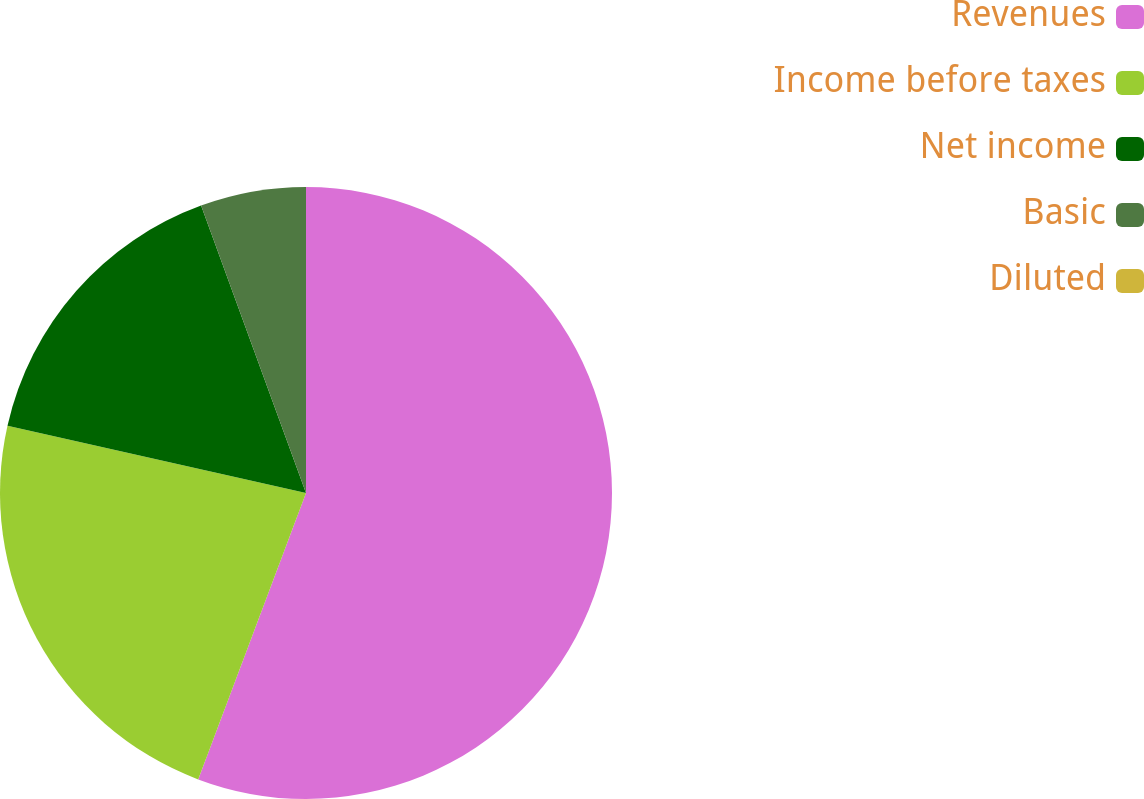Convert chart to OTSL. <chart><loc_0><loc_0><loc_500><loc_500><pie_chart><fcel>Revenues<fcel>Income before taxes<fcel>Net income<fcel>Basic<fcel>Diluted<nl><fcel>55.73%<fcel>22.8%<fcel>15.9%<fcel>5.57%<fcel>0.0%<nl></chart> 